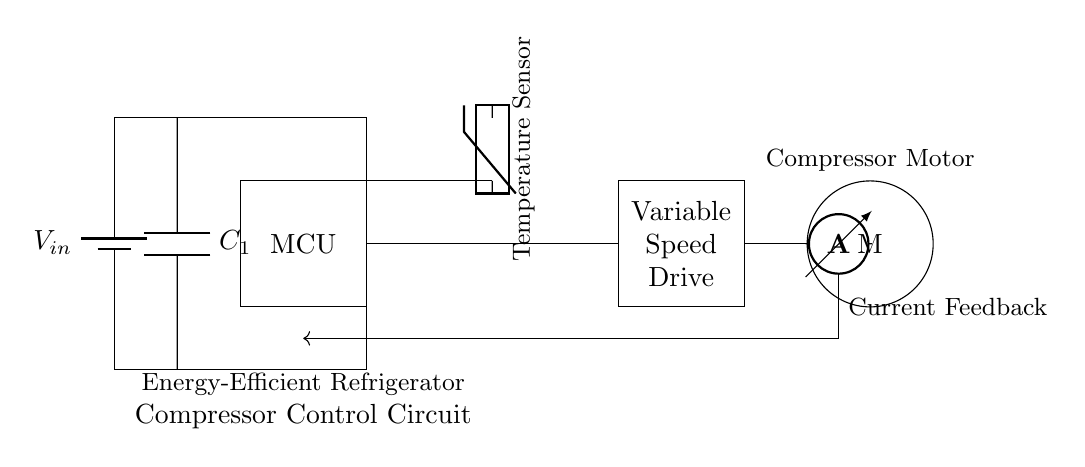What is the component that regulates the compressor's speed? The component responsible for regulating the compressor's speed is the Variable Speed Drive, which adjusts the motor speed based on feedback from various sensors in the circuit.
Answer: Variable Speed Drive What type of sensor is used in this circuit? The circuit uses a temperature sensor, which detects the temperature and provides input to the microcontroller for control decisions.
Answer: Temperature sensor What is the purpose of the capacitor in this circuit? The capacitor is used for power smoothing, providing stable voltage to the circuit by reducing fluctuations that may occur in the power supply.
Answer: Smoothing How does current feedback influence the circuit operation? Current feedback is transmitted to the microcontroller, helping it adjust the Variable Speed Drive's output to maintain optimum performance and efficiency based on the compressor's current operation.
Answer: Adjust performance What is the relationship between the microcontroller and the compressor motor? The microcontroller regulates the compressor motor's operation by processing inputs from the temperature sensor and current feedback, determining how fast the motor should run.
Answer: Regulation What kind of battery is indicated in the diagram? The battery type indicated in the diagram is a DC battery, denoted by the symbol for a battery with a single voltage source, supporting the entire circuit's power needs.
Answer: DC battery 